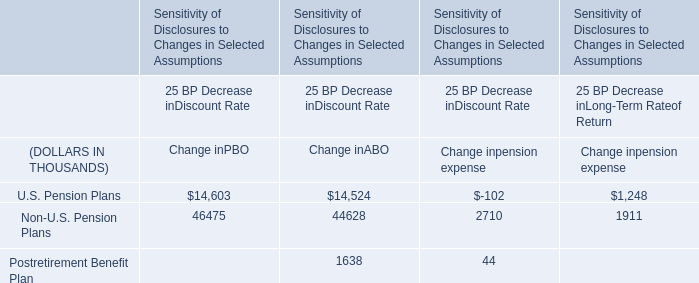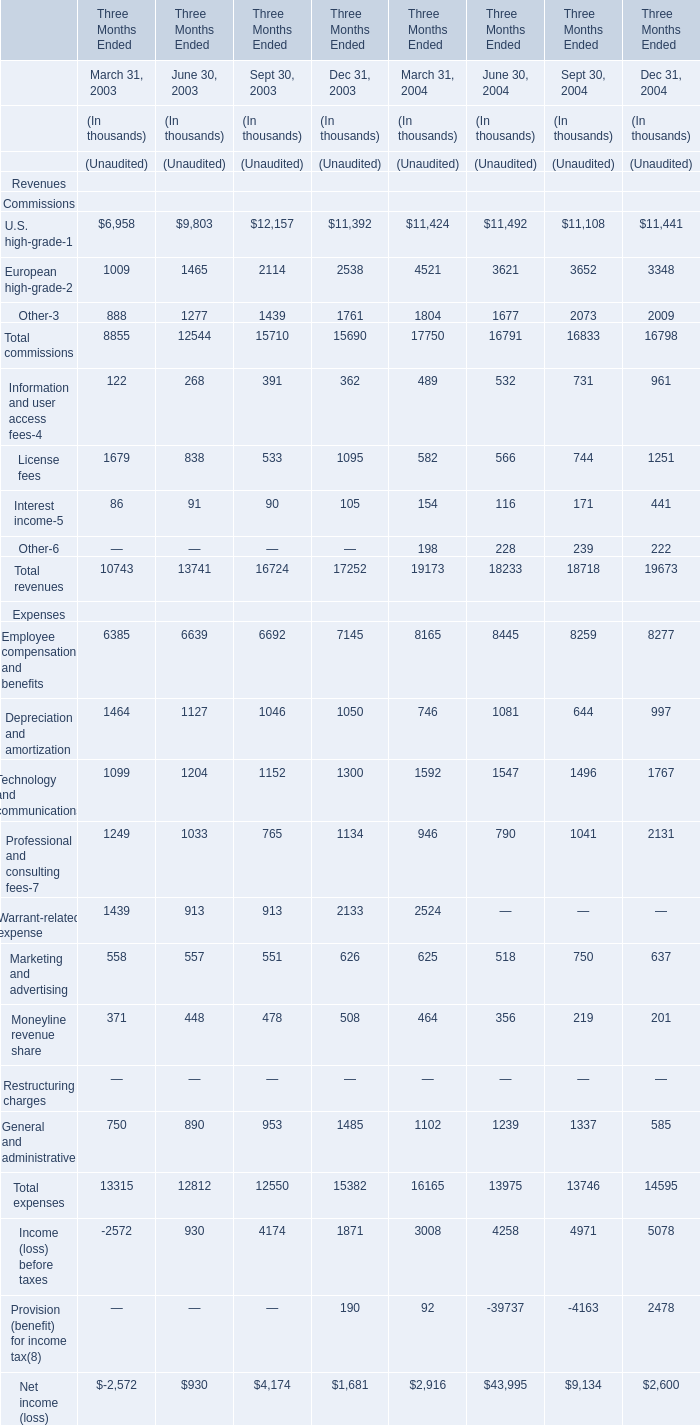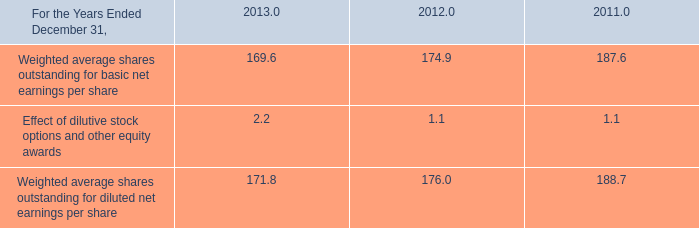what percent increase does dilutive stock have on the value of weighted shares outstanding for earnings per share in 2013? 
Computations: ((171.8 / 169.6) - 1)
Answer: 0.01297. 